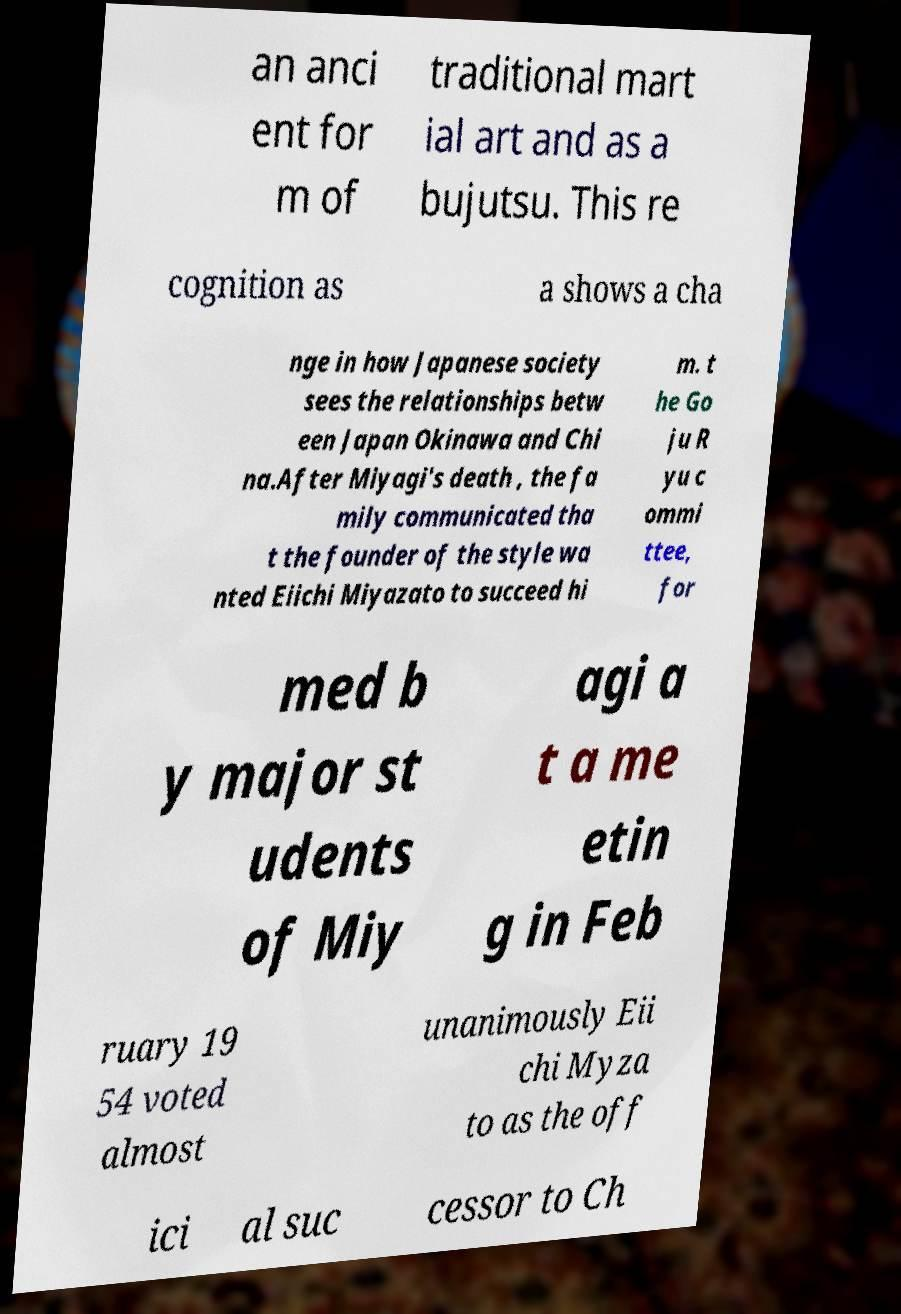Please identify and transcribe the text found in this image. an anci ent for m of traditional mart ial art and as a bujutsu. This re cognition as a shows a cha nge in how Japanese society sees the relationships betw een Japan Okinawa and Chi na.After Miyagi's death , the fa mily communicated tha t the founder of the style wa nted Eiichi Miyazato to succeed hi m. t he Go ju R yu c ommi ttee, for med b y major st udents of Miy agi a t a me etin g in Feb ruary 19 54 voted almost unanimously Eii chi Myza to as the off ici al suc cessor to Ch 